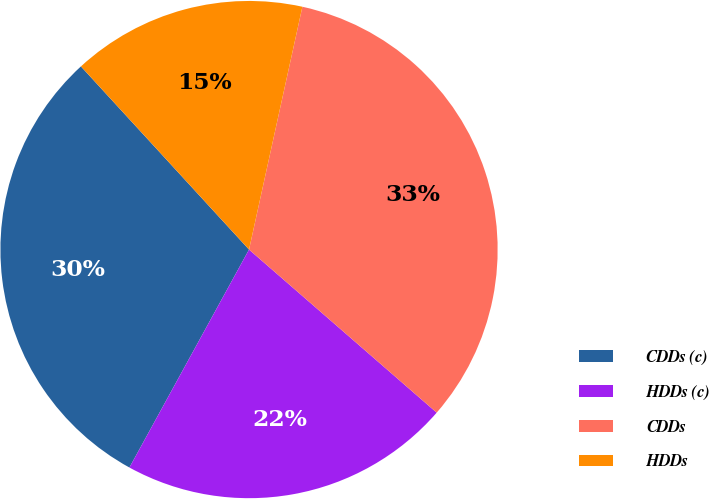Convert chart to OTSL. <chart><loc_0><loc_0><loc_500><loc_500><pie_chart><fcel>CDDs (c)<fcel>HDDs (c)<fcel>CDDs<fcel>HDDs<nl><fcel>30.19%<fcel>21.6%<fcel>32.94%<fcel>15.26%<nl></chart> 